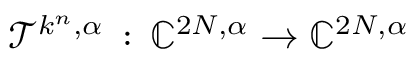Convert formula to latex. <formula><loc_0><loc_0><loc_500><loc_500>\mathcal { T } ^ { k ^ { n } , \alpha } \, \colon \, \mathbb { C } ^ { 2 N , \alpha } \to \mathbb { C } ^ { 2 N , \alpha }</formula> 